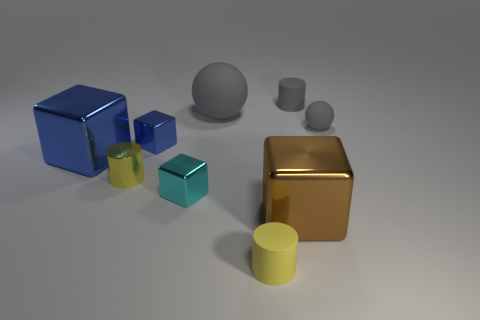The big metal object that is on the right side of the cyan object has what shape?
Provide a succinct answer. Cube. Is the number of small yellow cylinders to the left of the tiny cyan metal block less than the number of large rubber spheres to the left of the tiny yellow metallic cylinder?
Provide a short and direct response. No. Are the small block in front of the small metallic cylinder and the tiny yellow cylinder that is on the right side of the small cyan metal cube made of the same material?
Make the answer very short. No. What shape is the tiny cyan metal object?
Offer a terse response. Cube. Are there more rubber balls left of the large sphere than blue metal objects behind the tiny gray rubber cylinder?
Make the answer very short. No. Is the shape of the rubber object in front of the tiny yellow metallic object the same as the tiny yellow metal object behind the small cyan thing?
Your response must be concise. Yes. What number of other objects are the same size as the cyan metallic object?
Provide a succinct answer. 5. The gray rubber cylinder has what size?
Ensure brevity in your answer.  Small. Do the large cube on the right side of the large matte object and the small ball have the same material?
Offer a terse response. No. What is the color of the other large shiny thing that is the same shape as the big blue metallic thing?
Offer a very short reply. Brown. 